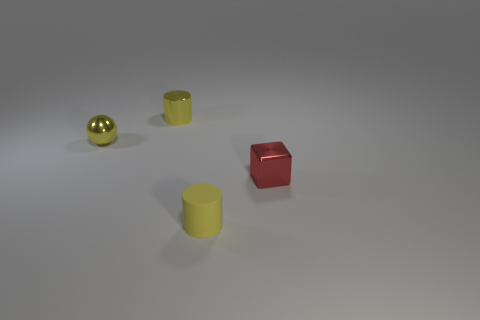Add 4 tiny cubes. How many objects exist? 8 Subtract all cubes. How many objects are left? 3 Subtract 0 blue cylinders. How many objects are left? 4 Subtract all small metallic cylinders. Subtract all tiny yellow metallic cylinders. How many objects are left? 2 Add 3 small shiny cylinders. How many small shiny cylinders are left? 4 Add 2 tiny red shiny objects. How many tiny red shiny objects exist? 3 